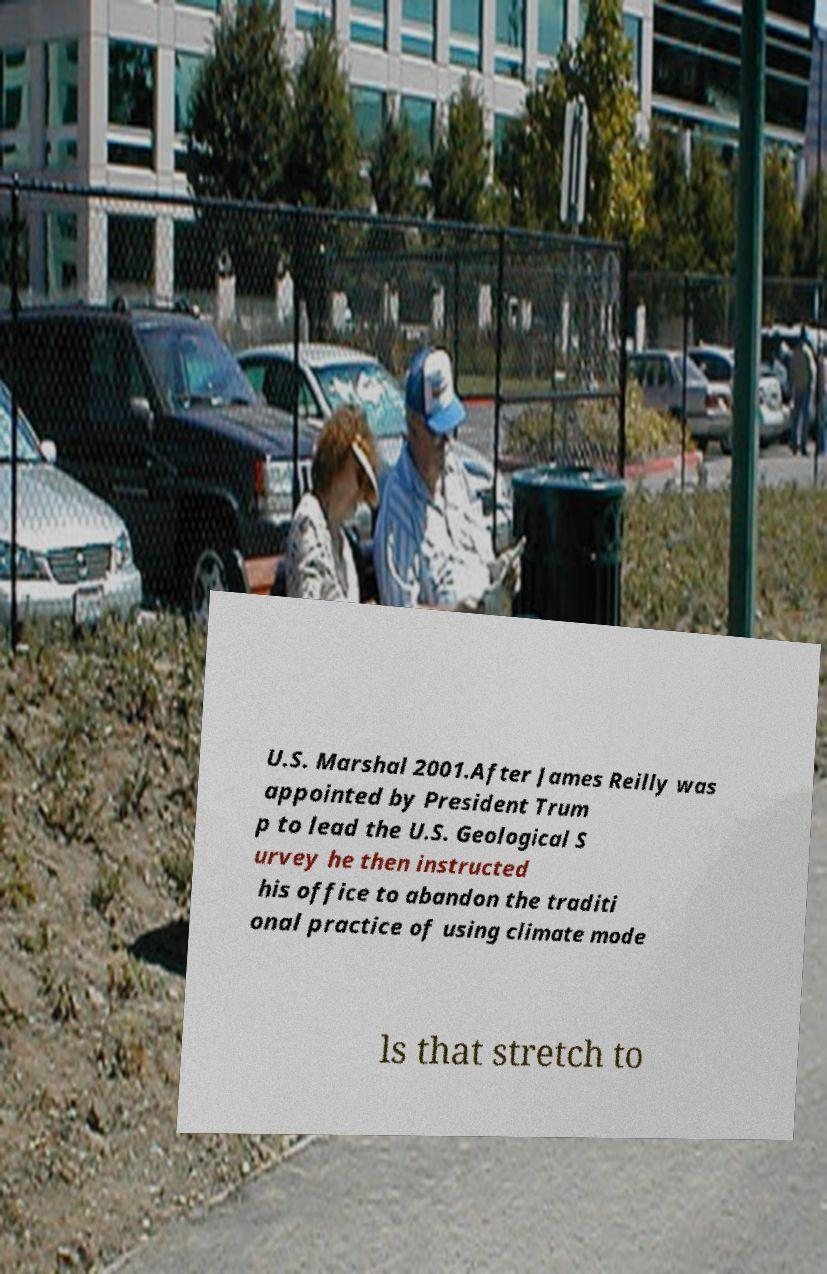Can you accurately transcribe the text from the provided image for me? U.S. Marshal 2001.After James Reilly was appointed by President Trum p to lead the U.S. Geological S urvey he then instructed his office to abandon the traditi onal practice of using climate mode ls that stretch to 